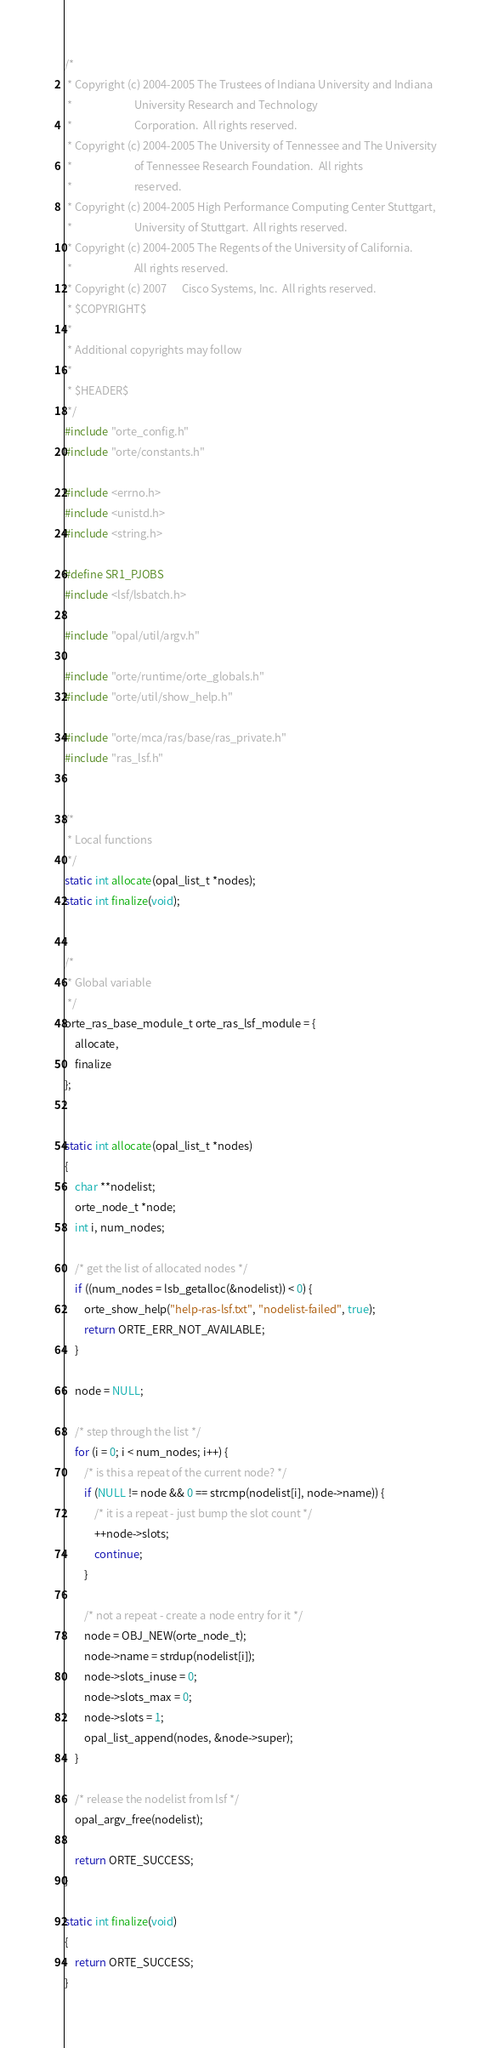Convert code to text. <code><loc_0><loc_0><loc_500><loc_500><_C_>/*
 * Copyright (c) 2004-2005 The Trustees of Indiana University and Indiana
 *                         University Research and Technology
 *                         Corporation.  All rights reserved.
 * Copyright (c) 2004-2005 The University of Tennessee and The University
 *                         of Tennessee Research Foundation.  All rights
 *                         reserved.
 * Copyright (c) 2004-2005 High Performance Computing Center Stuttgart, 
 *                         University of Stuttgart.  All rights reserved.
 * Copyright (c) 2004-2005 The Regents of the University of California.
 *                         All rights reserved.
 * Copyright (c) 2007      Cisco Systems, Inc.  All rights reserved.
 * $COPYRIGHT$
 * 
 * Additional copyrights may follow
 * 
 * $HEADER$
 */
#include "orte_config.h"
#include "orte/constants.h"

#include <errno.h>
#include <unistd.h>
#include <string.h>

#define SR1_PJOBS
#include <lsf/lsbatch.h>

#include "opal/util/argv.h"

#include "orte/runtime/orte_globals.h"
#include "orte/util/show_help.h"

#include "orte/mca/ras/base/ras_private.h"
#include "ras_lsf.h"


/*
 * Local functions
 */
static int allocate(opal_list_t *nodes);
static int finalize(void);


/*
 * Global variable
 */
orte_ras_base_module_t orte_ras_lsf_module = {
    allocate,
    finalize
};


static int allocate(opal_list_t *nodes)
{
    char **nodelist;
    orte_node_t *node;
    int i, num_nodes;

    /* get the list of allocated nodes */
    if ((num_nodes = lsb_getalloc(&nodelist)) < 0) {
        orte_show_help("help-ras-lsf.txt", "nodelist-failed", true);
        return ORTE_ERR_NOT_AVAILABLE;
    }
    
    node = NULL;
    
    /* step through the list */
    for (i = 0; i < num_nodes; i++) {
        /* is this a repeat of the current node? */
        if (NULL != node && 0 == strcmp(nodelist[i], node->name)) {
            /* it is a repeat - just bump the slot count */
            ++node->slots;
            continue;
        }
        
        /* not a repeat - create a node entry for it */
        node = OBJ_NEW(orte_node_t);
        node->name = strdup(nodelist[i]);
        node->slots_inuse = 0;
        node->slots_max = 0;
        node->slots = 1;
        opal_list_append(nodes, &node->super);
    }
        
    /* release the nodelist from lsf */
    opal_argv_free(nodelist);

    return ORTE_SUCCESS;
}

static int finalize(void)
{
    return ORTE_SUCCESS;
}
</code> 